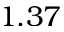Convert formula to latex. <formula><loc_0><loc_0><loc_500><loc_500>1 . 3 7</formula> 